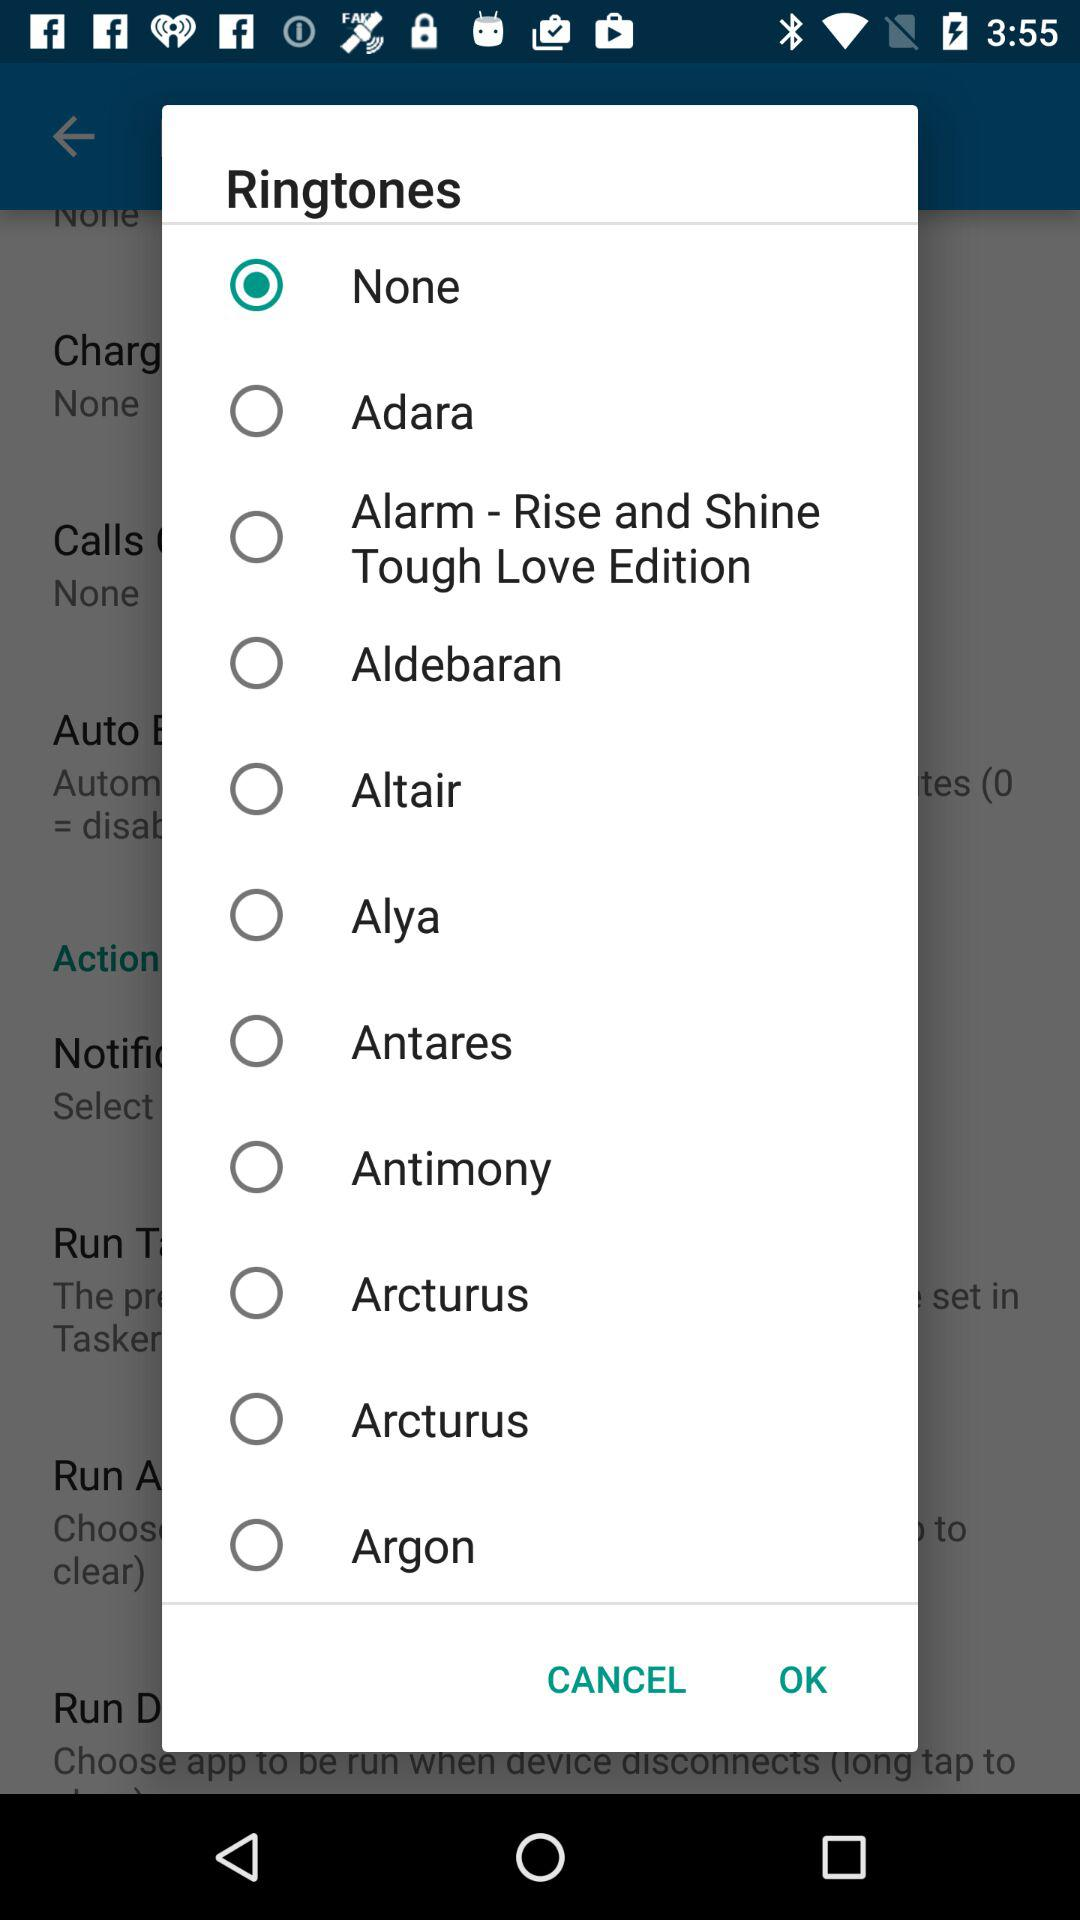Which ringtone is selected? The selected ringtone is "None". 